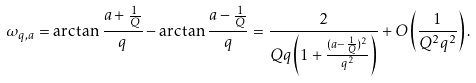Convert formula to latex. <formula><loc_0><loc_0><loc_500><loc_500>\omega _ { q , a } = \arctan \frac { a + \frac { 1 } { Q } } { q } - \arctan \frac { a - \frac { 1 } { Q } } { q } = \frac { 2 } { Q q \left ( 1 + \frac { ( a - \frac { 1 } { Q } ) ^ { 2 } } { q ^ { 2 } } \right ) } + O \left ( \frac { 1 } { Q ^ { 2 } q ^ { 2 } } \right ) .</formula> 